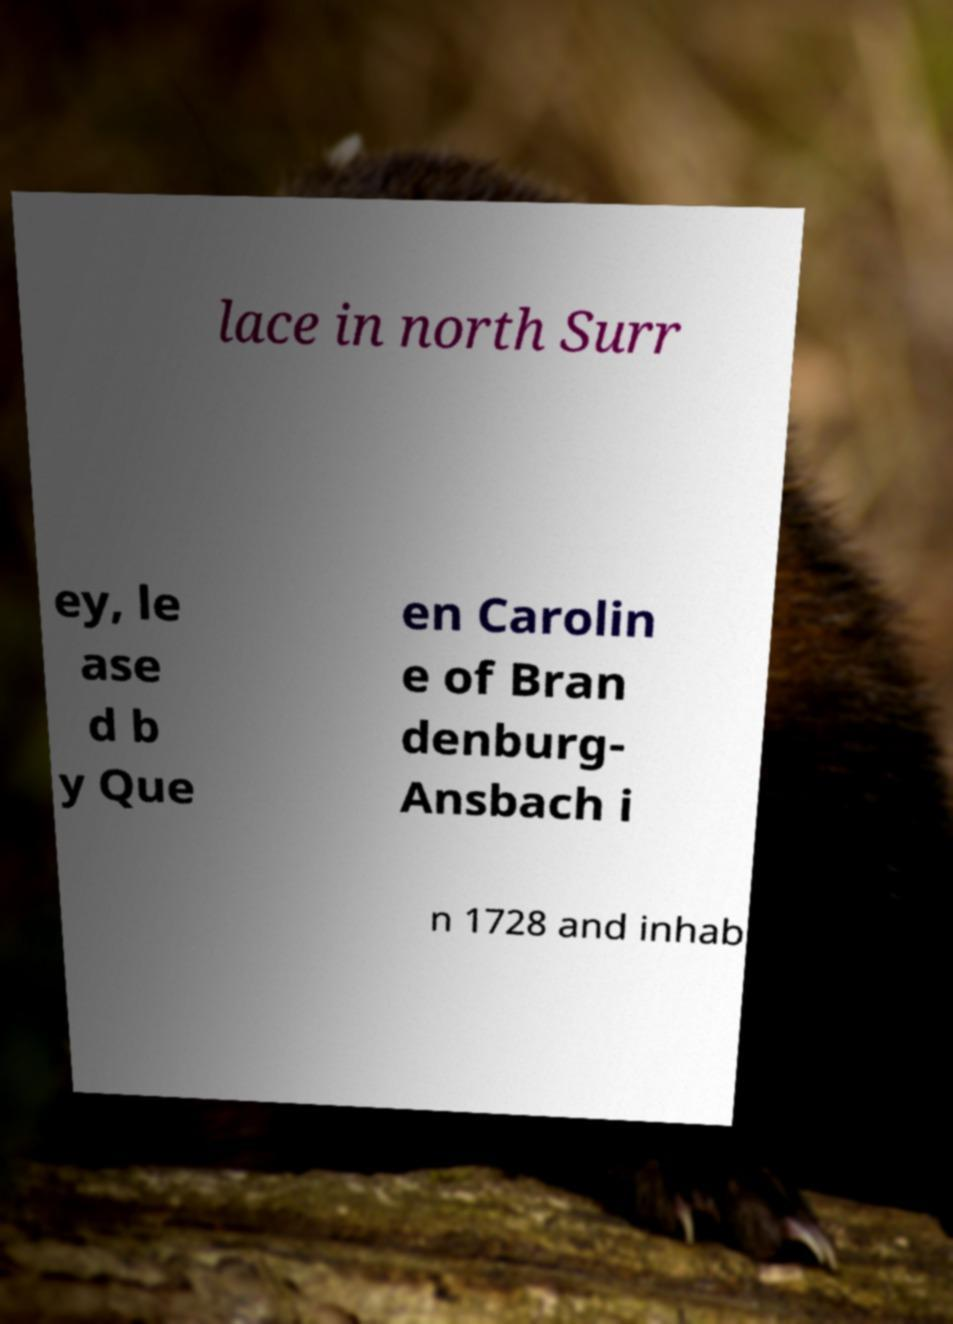There's text embedded in this image that I need extracted. Can you transcribe it verbatim? lace in north Surr ey, le ase d b y Que en Carolin e of Bran denburg- Ansbach i n 1728 and inhab 